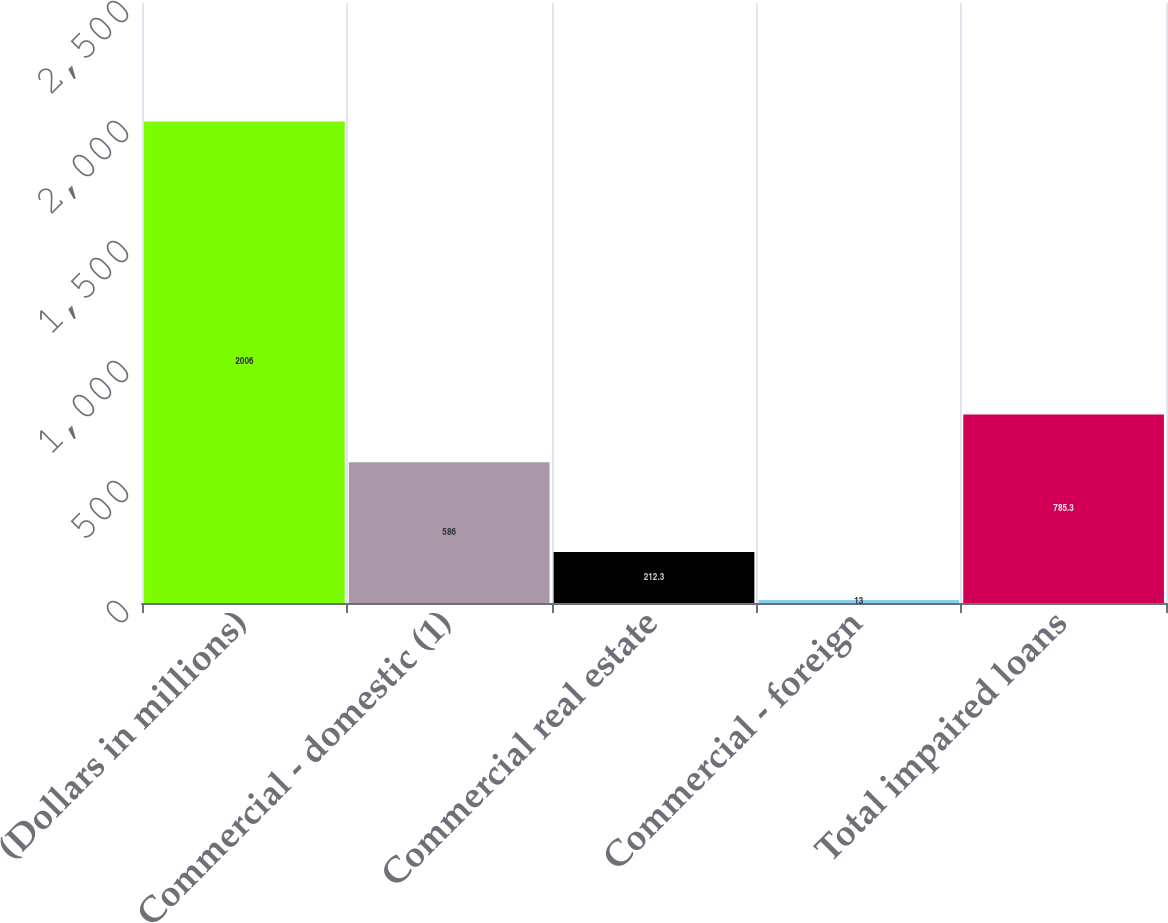Convert chart to OTSL. <chart><loc_0><loc_0><loc_500><loc_500><bar_chart><fcel>(Dollars in millions)<fcel>Commercial - domestic (1)<fcel>Commercial real estate<fcel>Commercial - foreign<fcel>Total impaired loans<nl><fcel>2006<fcel>586<fcel>212.3<fcel>13<fcel>785.3<nl></chart> 